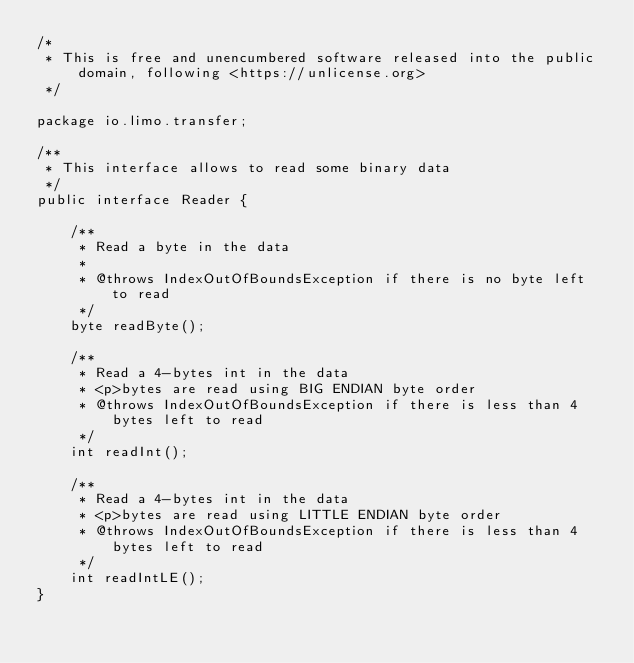Convert code to text. <code><loc_0><loc_0><loc_500><loc_500><_Java_>/*
 * This is free and unencumbered software released into the public domain, following <https://unlicense.org>
 */

package io.limo.transfer;

/**
 * This interface allows to read some binary data
 */
public interface Reader {

    /**
     * Read a byte in the data
     *
     * @throws IndexOutOfBoundsException if there is no byte left to read
     */
    byte readByte();

    /**
     * Read a 4-bytes int in the data
     * <p>bytes are read using BIG ENDIAN byte order
     * @throws IndexOutOfBoundsException if there is less than 4 bytes left to read
     */
    int readInt();

    /**
     * Read a 4-bytes int in the data
     * <p>bytes are read using LITTLE ENDIAN byte order
     * @throws IndexOutOfBoundsException if there is less than 4 bytes left to read
     */
    int readIntLE();
}
</code> 